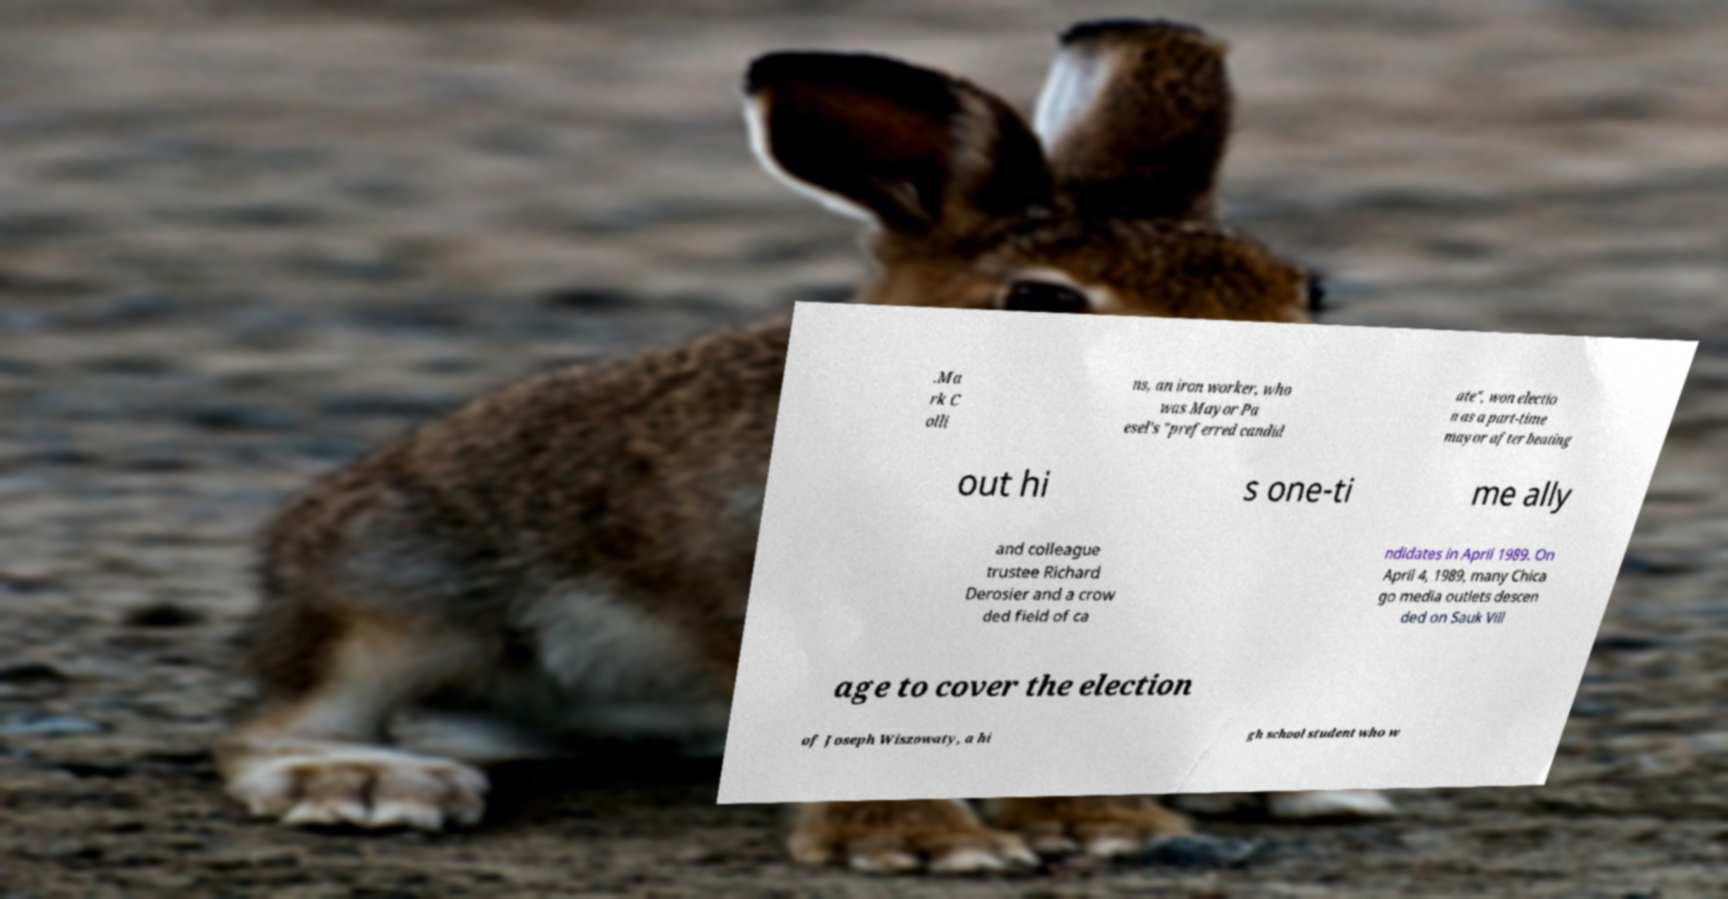What messages or text are displayed in this image? I need them in a readable, typed format. .Ma rk C olli ns, an iron worker, who was Mayor Pa esel's "preferred candid ate", won electio n as a part-time mayor after beating out hi s one-ti me ally and colleague trustee Richard Derosier and a crow ded field of ca ndidates in April 1989. On April 4, 1989, many Chica go media outlets descen ded on Sauk Vill age to cover the election of Joseph Wiszowaty, a hi gh school student who w 